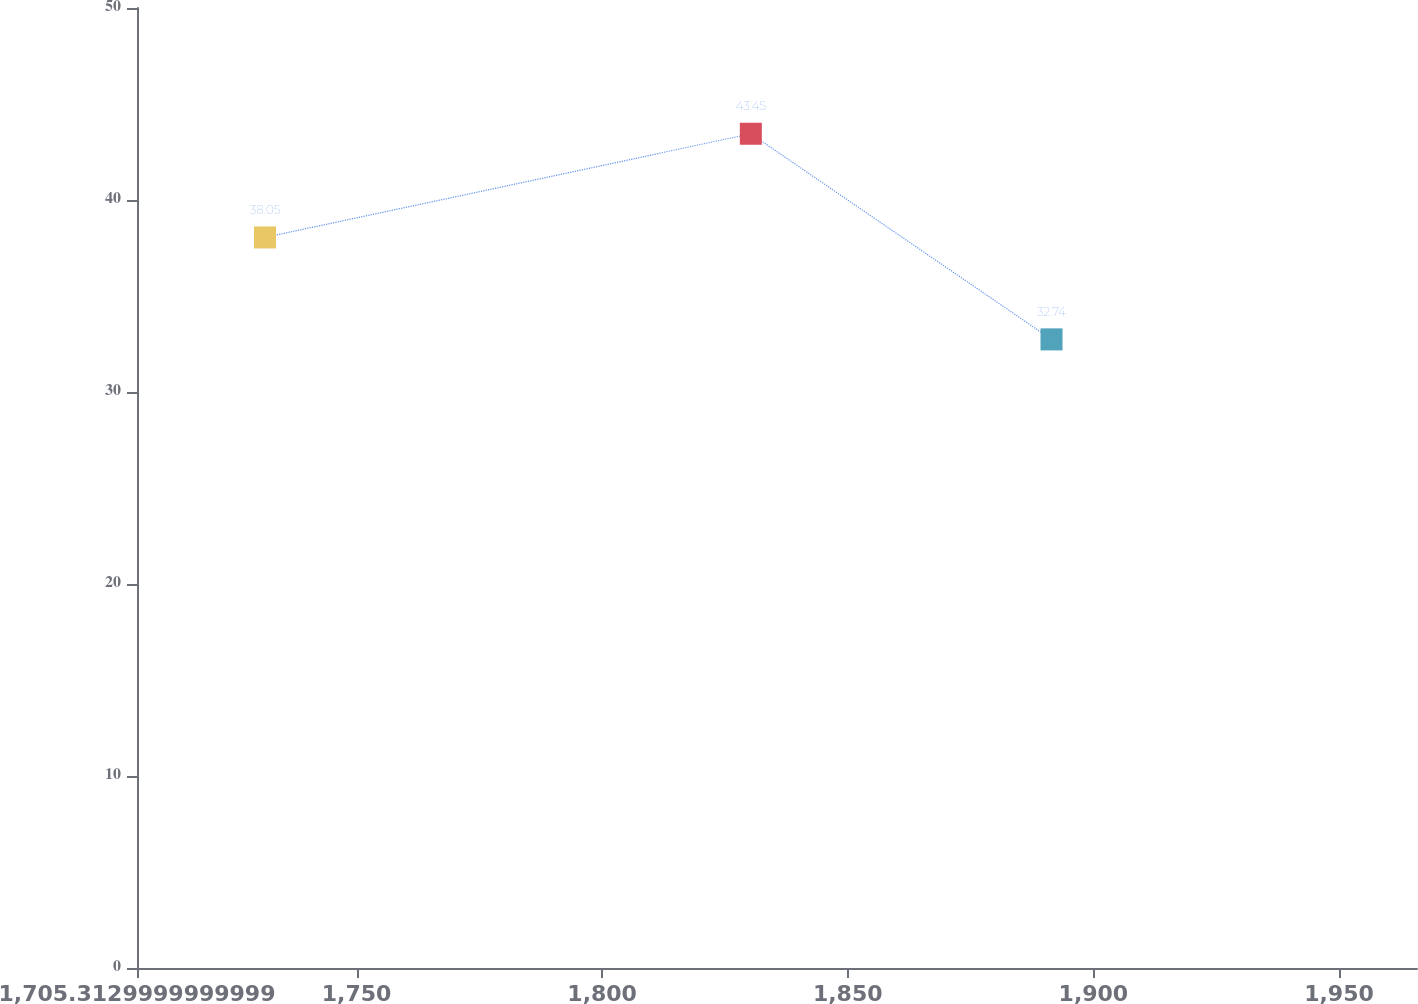Convert chart. <chart><loc_0><loc_0><loc_500><loc_500><line_chart><ecel><fcel>$ 33<nl><fcel>1731.37<fcel>38.05<nl><fcel>1830.27<fcel>43.45<nl><fcel>1891.48<fcel>32.74<nl><fcel>1991.94<fcel>40.98<nl></chart> 